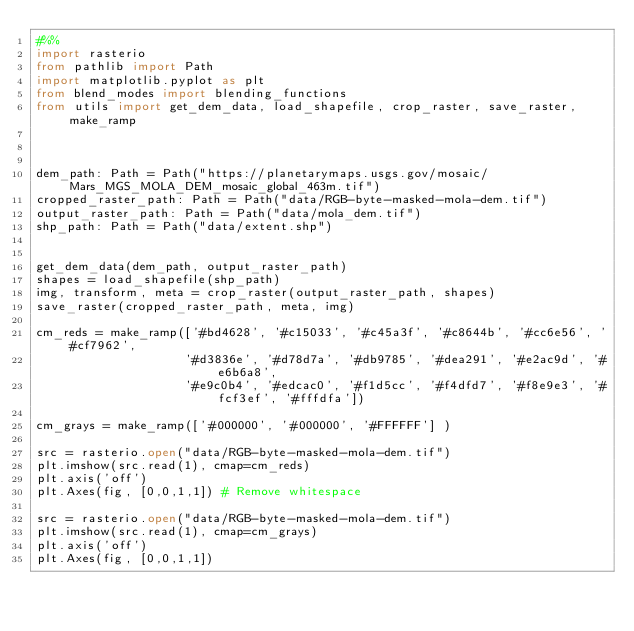<code> <loc_0><loc_0><loc_500><loc_500><_Python_>#%%
import rasterio
from pathlib import Path
import matplotlib.pyplot as plt
from blend_modes import blending_functions
from utils import get_dem_data, load_shapefile, crop_raster, save_raster, make_ramp



dem_path: Path = Path("https://planetarymaps.usgs.gov/mosaic/Mars_MGS_MOLA_DEM_mosaic_global_463m.tif")
cropped_raster_path: Path = Path("data/RGB-byte-masked-mola-dem.tif")
output_raster_path: Path = Path("data/mola_dem.tif")
shp_path: Path = Path("data/extent.shp")


get_dem_data(dem_path, output_raster_path)
shapes = load_shapefile(shp_path)
img, transform, meta = crop_raster(output_raster_path, shapes)
save_raster(cropped_raster_path, meta, img)

cm_reds = make_ramp(['#bd4628', '#c15033', '#c45a3f', '#c8644b', '#cc6e56', '#cf7962', 
                    '#d3836e', '#d78d7a', '#db9785', '#dea291', '#e2ac9d', '#e6b6a8', 
                    '#e9c0b4', '#edcac0', '#f1d5cc', '#f4dfd7', '#f8e9e3', '#fcf3ef', '#fffdfa'])

cm_grays = make_ramp(['#000000', '#000000', '#FFFFFF'] )

src = rasterio.open("data/RGB-byte-masked-mola-dem.tif")
plt.imshow(src.read(1), cmap=cm_reds)
plt.axis('off')
plt.Axes(fig, [0,0,1,1]) # Remove whitespace

src = rasterio.open("data/RGB-byte-masked-mola-dem.tif")
plt.imshow(src.read(1), cmap=cm_grays)
plt.axis('off')
plt.Axes(fig, [0,0,1,1])
</code> 